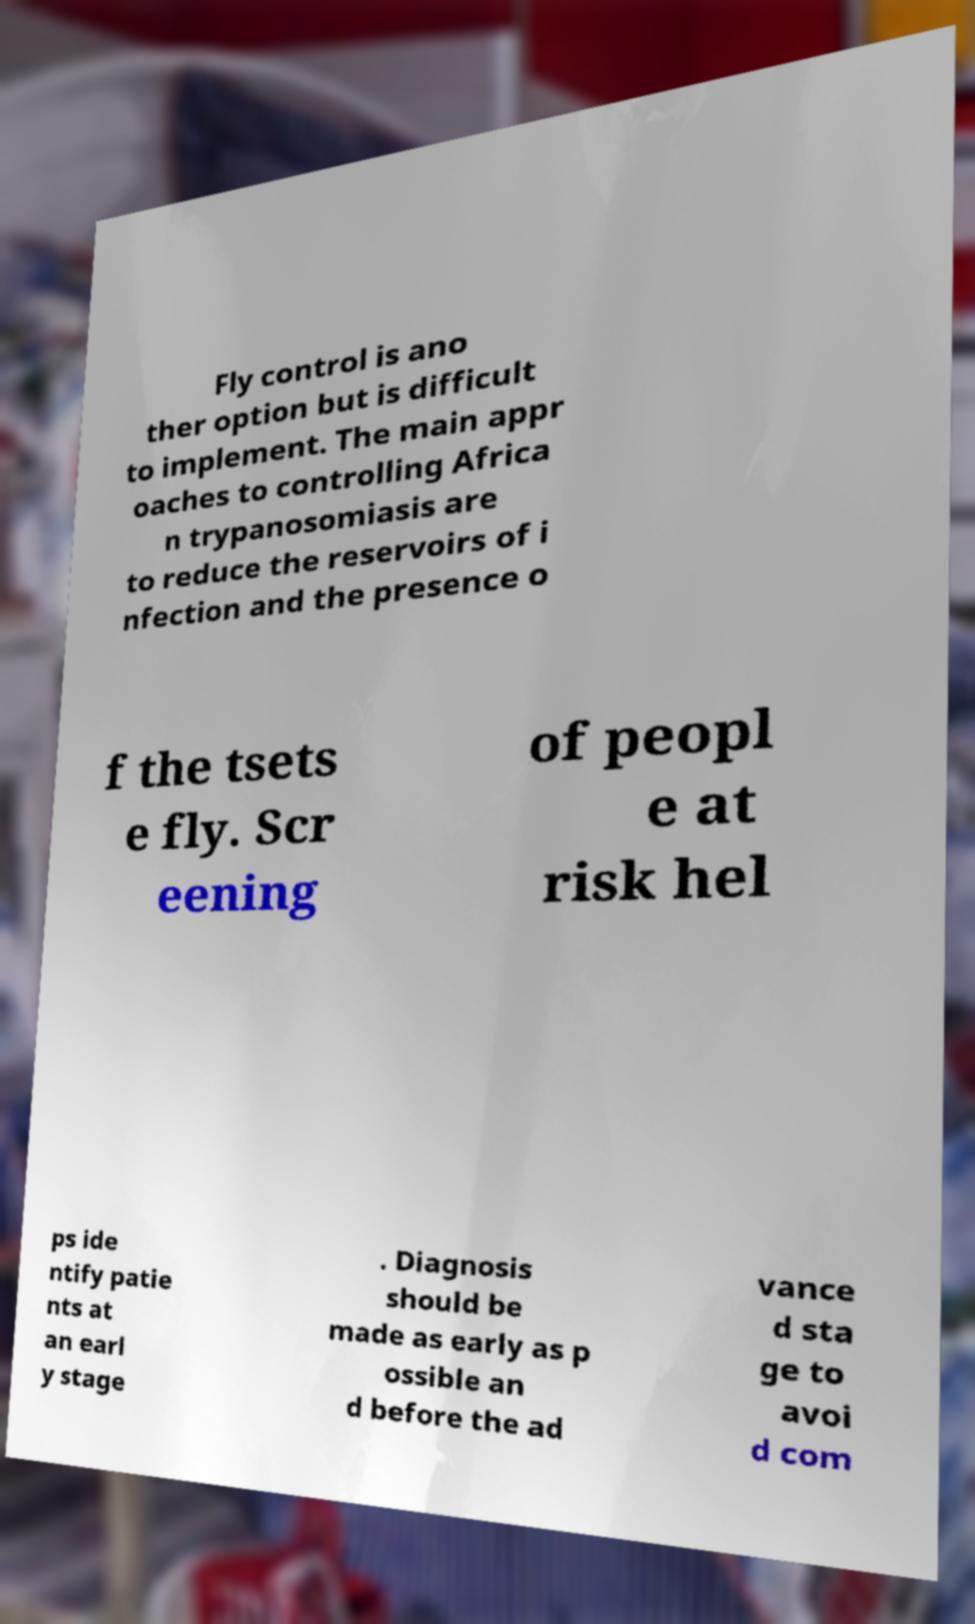What messages or text are displayed in this image? I need them in a readable, typed format. Fly control is ano ther option but is difficult to implement. The main appr oaches to controlling Africa n trypanosomiasis are to reduce the reservoirs of i nfection and the presence o f the tsets e fly. Scr eening of peopl e at risk hel ps ide ntify patie nts at an earl y stage . Diagnosis should be made as early as p ossible an d before the ad vance d sta ge to avoi d com 